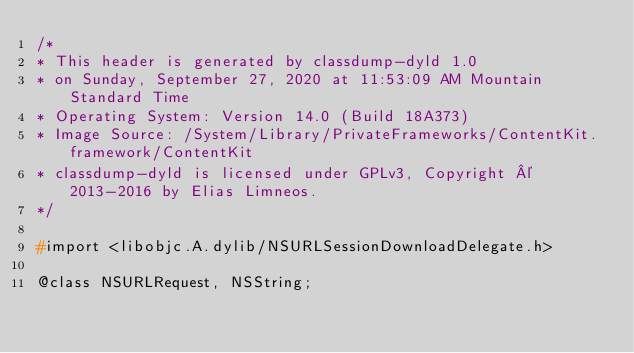Convert code to text. <code><loc_0><loc_0><loc_500><loc_500><_C_>/*
* This header is generated by classdump-dyld 1.0
* on Sunday, September 27, 2020 at 11:53:09 AM Mountain Standard Time
* Operating System: Version 14.0 (Build 18A373)
* Image Source: /System/Library/PrivateFrameworks/ContentKit.framework/ContentKit
* classdump-dyld is licensed under GPLv3, Copyright © 2013-2016 by Elias Limneos.
*/

#import <libobjc.A.dylib/NSURLSessionDownloadDelegate.h>

@class NSURLRequest, NSString;
</code> 